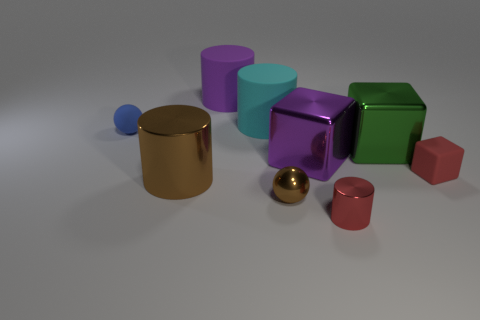Subtract 1 cylinders. How many cylinders are left? 3 Subtract all cyan cylinders. How many cylinders are left? 3 Subtract all big cyan rubber cylinders. How many cylinders are left? 3 Add 1 red objects. How many objects exist? 10 Subtract all cyan cylinders. Subtract all blue cubes. How many cylinders are left? 3 Subtract all cylinders. How many objects are left? 5 Add 1 cyan things. How many cyan things are left? 2 Add 3 small cubes. How many small cubes exist? 4 Subtract 1 brown cylinders. How many objects are left? 8 Subtract all big purple objects. Subtract all red metal balls. How many objects are left? 7 